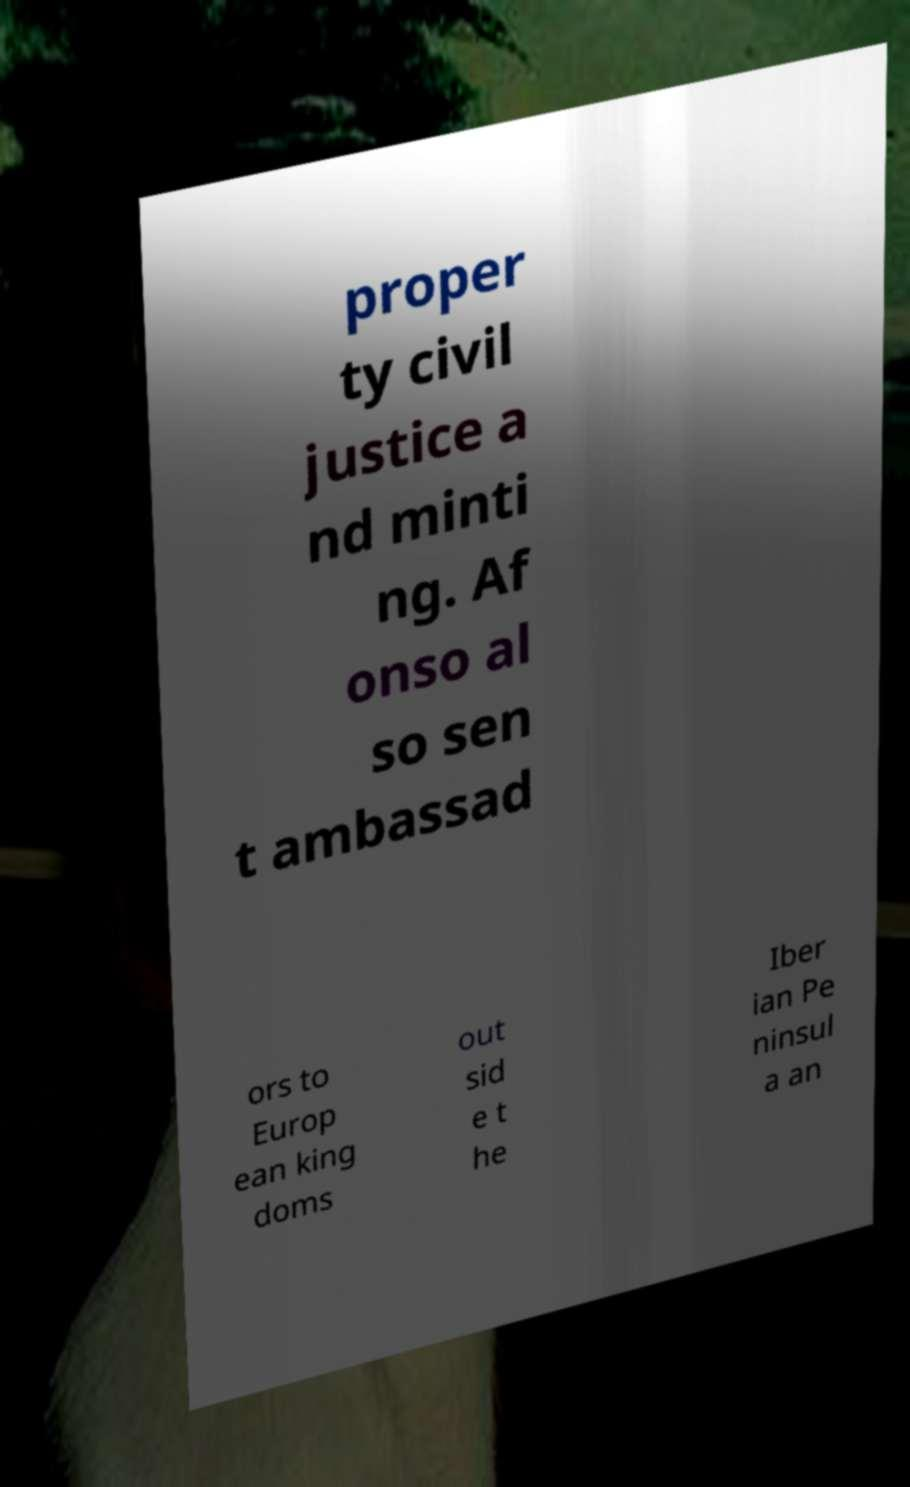I need the written content from this picture converted into text. Can you do that? proper ty civil justice a nd minti ng. Af onso al so sen t ambassad ors to Europ ean king doms out sid e t he Iber ian Pe ninsul a an 